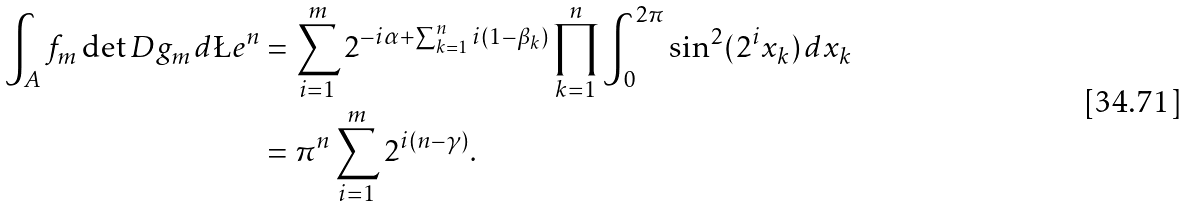<formula> <loc_0><loc_0><loc_500><loc_500>\int _ { A } f _ { m } \det D g _ { m } \, d \L e ^ { n } & = \sum _ { i = 1 } ^ { m } 2 ^ { - i \alpha + \sum _ { k = 1 } ^ { n } i ( 1 - \beta _ { k } ) } \prod _ { k = 1 } ^ { n } \int _ { 0 } ^ { 2 \pi } \sin ^ { 2 } ( 2 ^ { i } x _ { k } ) \, d x _ { k } \\ & = \pi ^ { n } \sum _ { i = 1 } ^ { m } 2 ^ { i ( n - \gamma ) } .</formula> 